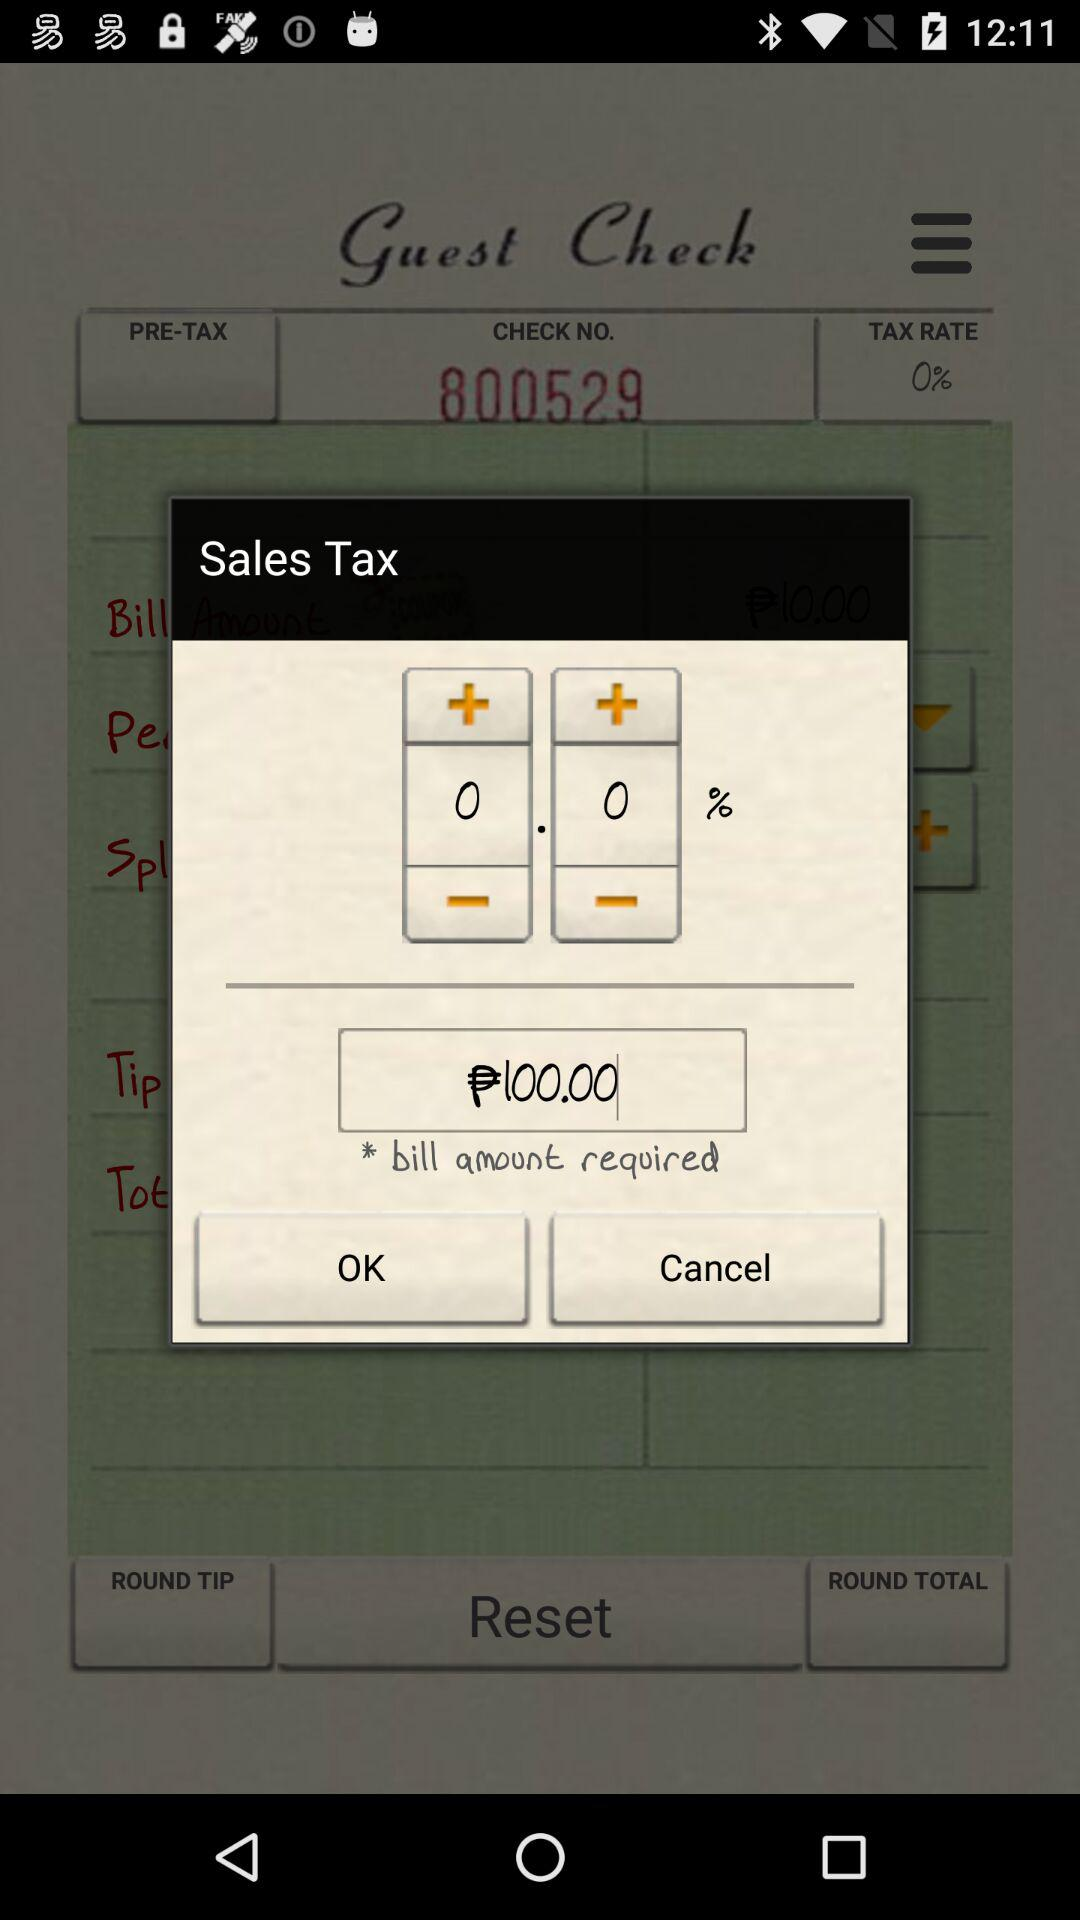How much of a bill amount is required? The amount required is ₱100. 